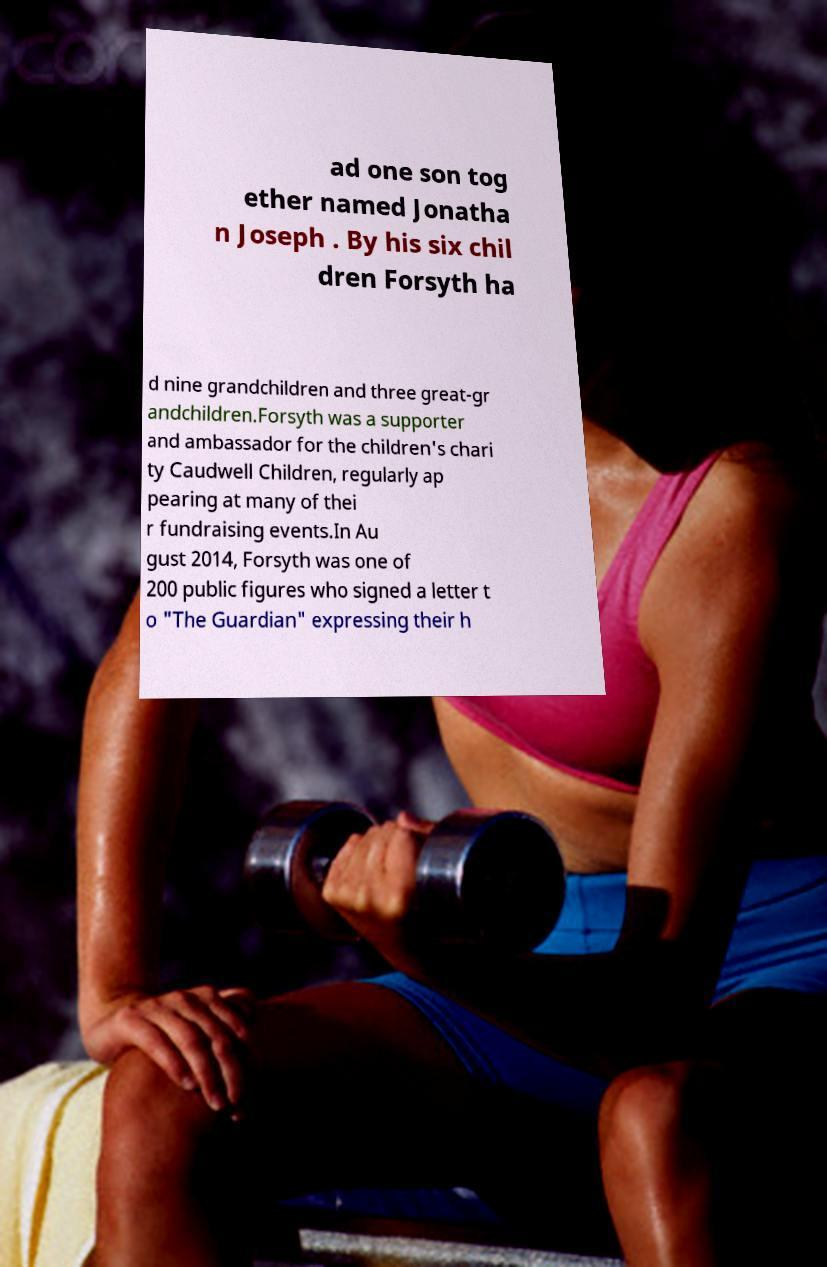There's text embedded in this image that I need extracted. Can you transcribe it verbatim? ad one son tog ether named Jonatha n Joseph . By his six chil dren Forsyth ha d nine grandchildren and three great-gr andchildren.Forsyth was a supporter and ambassador for the children's chari ty Caudwell Children, regularly ap pearing at many of thei r fundraising events.In Au gust 2014, Forsyth was one of 200 public figures who signed a letter t o "The Guardian" expressing their h 